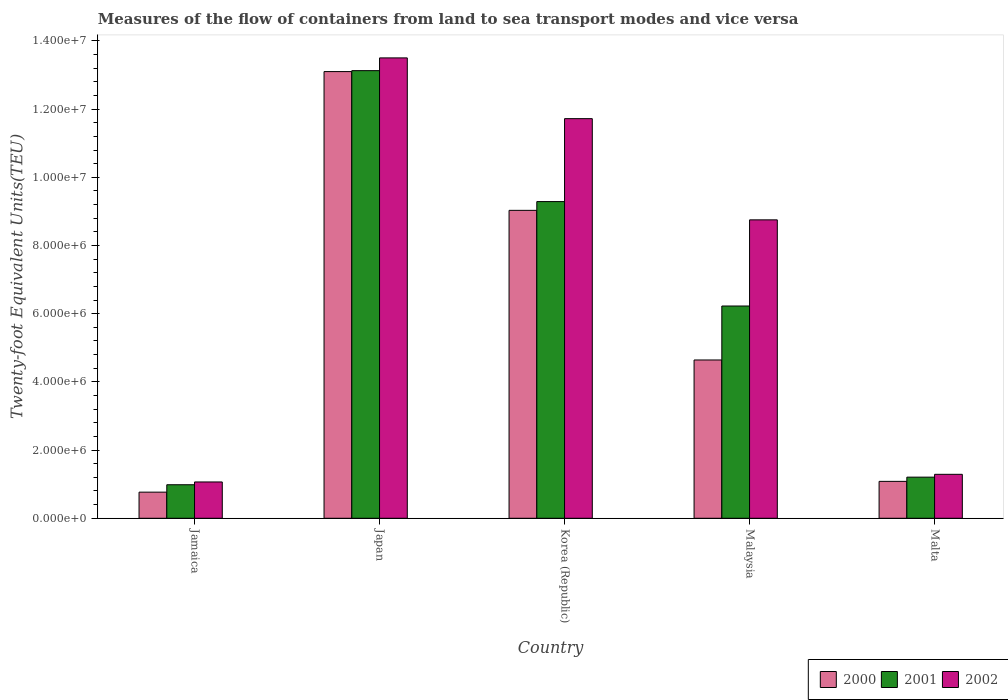How many groups of bars are there?
Offer a terse response. 5. Are the number of bars per tick equal to the number of legend labels?
Offer a very short reply. Yes. What is the label of the 1st group of bars from the left?
Provide a succinct answer. Jamaica. What is the container port traffic in 2001 in Korea (Republic)?
Your answer should be very brief. 9.29e+06. Across all countries, what is the maximum container port traffic in 2002?
Your response must be concise. 1.35e+07. Across all countries, what is the minimum container port traffic in 2000?
Give a very brief answer. 7.66e+05. In which country was the container port traffic in 2000 minimum?
Keep it short and to the point. Jamaica. What is the total container port traffic in 2000 in the graph?
Provide a succinct answer. 2.86e+07. What is the difference between the container port traffic in 2002 in Korea (Republic) and that in Malaysia?
Provide a succinct answer. 2.97e+06. What is the difference between the container port traffic in 2000 in Jamaica and the container port traffic in 2002 in Malaysia?
Offer a terse response. -7.99e+06. What is the average container port traffic in 2000 per country?
Provide a short and direct response. 5.72e+06. What is the difference between the container port traffic of/in 2001 and container port traffic of/in 2000 in Korea (Republic)?
Keep it short and to the point. 2.57e+05. What is the ratio of the container port traffic in 2001 in Jamaica to that in Japan?
Provide a short and direct response. 0.07. What is the difference between the highest and the second highest container port traffic in 2001?
Keep it short and to the point. 6.90e+06. What is the difference between the highest and the lowest container port traffic in 2002?
Keep it short and to the point. 1.24e+07. In how many countries, is the container port traffic in 2000 greater than the average container port traffic in 2000 taken over all countries?
Provide a short and direct response. 2. What does the 1st bar from the left in Japan represents?
Keep it short and to the point. 2000. How many bars are there?
Ensure brevity in your answer.  15. How many countries are there in the graph?
Make the answer very short. 5. What is the difference between two consecutive major ticks on the Y-axis?
Make the answer very short. 2.00e+06. Does the graph contain grids?
Your answer should be very brief. No. How many legend labels are there?
Your response must be concise. 3. How are the legend labels stacked?
Give a very brief answer. Horizontal. What is the title of the graph?
Provide a succinct answer. Measures of the flow of containers from land to sea transport modes and vice versa. What is the label or title of the X-axis?
Offer a terse response. Country. What is the label or title of the Y-axis?
Make the answer very short. Twenty-foot Equivalent Units(TEU). What is the Twenty-foot Equivalent Units(TEU) in 2000 in Jamaica?
Your response must be concise. 7.66e+05. What is the Twenty-foot Equivalent Units(TEU) of 2001 in Jamaica?
Provide a succinct answer. 9.83e+05. What is the Twenty-foot Equivalent Units(TEU) in 2002 in Jamaica?
Keep it short and to the point. 1.06e+06. What is the Twenty-foot Equivalent Units(TEU) of 2000 in Japan?
Provide a short and direct response. 1.31e+07. What is the Twenty-foot Equivalent Units(TEU) of 2001 in Japan?
Provide a short and direct response. 1.31e+07. What is the Twenty-foot Equivalent Units(TEU) in 2002 in Japan?
Make the answer very short. 1.35e+07. What is the Twenty-foot Equivalent Units(TEU) of 2000 in Korea (Republic)?
Make the answer very short. 9.03e+06. What is the Twenty-foot Equivalent Units(TEU) of 2001 in Korea (Republic)?
Keep it short and to the point. 9.29e+06. What is the Twenty-foot Equivalent Units(TEU) in 2002 in Korea (Republic)?
Offer a very short reply. 1.17e+07. What is the Twenty-foot Equivalent Units(TEU) in 2000 in Malaysia?
Your answer should be very brief. 4.64e+06. What is the Twenty-foot Equivalent Units(TEU) in 2001 in Malaysia?
Offer a very short reply. 6.22e+06. What is the Twenty-foot Equivalent Units(TEU) in 2002 in Malaysia?
Provide a short and direct response. 8.75e+06. What is the Twenty-foot Equivalent Units(TEU) in 2000 in Malta?
Your answer should be compact. 1.08e+06. What is the Twenty-foot Equivalent Units(TEU) in 2001 in Malta?
Offer a very short reply. 1.21e+06. What is the Twenty-foot Equivalent Units(TEU) of 2002 in Malta?
Your answer should be compact. 1.29e+06. Across all countries, what is the maximum Twenty-foot Equivalent Units(TEU) in 2000?
Provide a short and direct response. 1.31e+07. Across all countries, what is the maximum Twenty-foot Equivalent Units(TEU) in 2001?
Keep it short and to the point. 1.31e+07. Across all countries, what is the maximum Twenty-foot Equivalent Units(TEU) of 2002?
Keep it short and to the point. 1.35e+07. Across all countries, what is the minimum Twenty-foot Equivalent Units(TEU) in 2000?
Ensure brevity in your answer.  7.66e+05. Across all countries, what is the minimum Twenty-foot Equivalent Units(TEU) in 2001?
Ensure brevity in your answer.  9.83e+05. Across all countries, what is the minimum Twenty-foot Equivalent Units(TEU) of 2002?
Offer a very short reply. 1.06e+06. What is the total Twenty-foot Equivalent Units(TEU) of 2000 in the graph?
Offer a terse response. 2.86e+07. What is the total Twenty-foot Equivalent Units(TEU) of 2001 in the graph?
Your response must be concise. 3.08e+07. What is the total Twenty-foot Equivalent Units(TEU) in 2002 in the graph?
Your answer should be very brief. 3.63e+07. What is the difference between the Twenty-foot Equivalent Units(TEU) of 2000 in Jamaica and that in Japan?
Keep it short and to the point. -1.23e+07. What is the difference between the Twenty-foot Equivalent Units(TEU) of 2001 in Jamaica and that in Japan?
Give a very brief answer. -1.21e+07. What is the difference between the Twenty-foot Equivalent Units(TEU) in 2002 in Jamaica and that in Japan?
Your response must be concise. -1.24e+07. What is the difference between the Twenty-foot Equivalent Units(TEU) of 2000 in Jamaica and that in Korea (Republic)?
Offer a very short reply. -8.26e+06. What is the difference between the Twenty-foot Equivalent Units(TEU) of 2001 in Jamaica and that in Korea (Republic)?
Offer a very short reply. -8.30e+06. What is the difference between the Twenty-foot Equivalent Units(TEU) of 2002 in Jamaica and that in Korea (Republic)?
Your response must be concise. -1.07e+07. What is the difference between the Twenty-foot Equivalent Units(TEU) of 2000 in Jamaica and that in Malaysia?
Give a very brief answer. -3.88e+06. What is the difference between the Twenty-foot Equivalent Units(TEU) in 2001 in Jamaica and that in Malaysia?
Provide a short and direct response. -5.24e+06. What is the difference between the Twenty-foot Equivalent Units(TEU) of 2002 in Jamaica and that in Malaysia?
Provide a succinct answer. -7.69e+06. What is the difference between the Twenty-foot Equivalent Units(TEU) of 2000 in Jamaica and that in Malta?
Your answer should be very brief. -3.16e+05. What is the difference between the Twenty-foot Equivalent Units(TEU) of 2001 in Jamaica and that in Malta?
Your answer should be very brief. -2.22e+05. What is the difference between the Twenty-foot Equivalent Units(TEU) of 2002 in Jamaica and that in Malta?
Provide a short and direct response. -2.24e+05. What is the difference between the Twenty-foot Equivalent Units(TEU) in 2000 in Japan and that in Korea (Republic)?
Your answer should be compact. 4.07e+06. What is the difference between the Twenty-foot Equivalent Units(TEU) in 2001 in Japan and that in Korea (Republic)?
Your response must be concise. 3.84e+06. What is the difference between the Twenty-foot Equivalent Units(TEU) in 2002 in Japan and that in Korea (Republic)?
Your answer should be very brief. 1.78e+06. What is the difference between the Twenty-foot Equivalent Units(TEU) of 2000 in Japan and that in Malaysia?
Provide a succinct answer. 8.46e+06. What is the difference between the Twenty-foot Equivalent Units(TEU) in 2001 in Japan and that in Malaysia?
Your response must be concise. 6.90e+06. What is the difference between the Twenty-foot Equivalent Units(TEU) in 2002 in Japan and that in Malaysia?
Your response must be concise. 4.75e+06. What is the difference between the Twenty-foot Equivalent Units(TEU) in 2000 in Japan and that in Malta?
Provide a succinct answer. 1.20e+07. What is the difference between the Twenty-foot Equivalent Units(TEU) of 2001 in Japan and that in Malta?
Provide a succinct answer. 1.19e+07. What is the difference between the Twenty-foot Equivalent Units(TEU) in 2002 in Japan and that in Malta?
Keep it short and to the point. 1.22e+07. What is the difference between the Twenty-foot Equivalent Units(TEU) in 2000 in Korea (Republic) and that in Malaysia?
Offer a terse response. 4.39e+06. What is the difference between the Twenty-foot Equivalent Units(TEU) in 2001 in Korea (Republic) and that in Malaysia?
Keep it short and to the point. 3.06e+06. What is the difference between the Twenty-foot Equivalent Units(TEU) in 2002 in Korea (Republic) and that in Malaysia?
Provide a succinct answer. 2.97e+06. What is the difference between the Twenty-foot Equivalent Units(TEU) of 2000 in Korea (Republic) and that in Malta?
Your response must be concise. 7.95e+06. What is the difference between the Twenty-foot Equivalent Units(TEU) of 2001 in Korea (Republic) and that in Malta?
Your response must be concise. 8.08e+06. What is the difference between the Twenty-foot Equivalent Units(TEU) in 2002 in Korea (Republic) and that in Malta?
Offer a very short reply. 1.04e+07. What is the difference between the Twenty-foot Equivalent Units(TEU) in 2000 in Malaysia and that in Malta?
Provide a succinct answer. 3.56e+06. What is the difference between the Twenty-foot Equivalent Units(TEU) in 2001 in Malaysia and that in Malta?
Offer a very short reply. 5.02e+06. What is the difference between the Twenty-foot Equivalent Units(TEU) of 2002 in Malaysia and that in Malta?
Offer a very short reply. 7.46e+06. What is the difference between the Twenty-foot Equivalent Units(TEU) in 2000 in Jamaica and the Twenty-foot Equivalent Units(TEU) in 2001 in Japan?
Give a very brief answer. -1.24e+07. What is the difference between the Twenty-foot Equivalent Units(TEU) of 2000 in Jamaica and the Twenty-foot Equivalent Units(TEU) of 2002 in Japan?
Provide a short and direct response. -1.27e+07. What is the difference between the Twenty-foot Equivalent Units(TEU) of 2001 in Jamaica and the Twenty-foot Equivalent Units(TEU) of 2002 in Japan?
Your answer should be compact. -1.25e+07. What is the difference between the Twenty-foot Equivalent Units(TEU) in 2000 in Jamaica and the Twenty-foot Equivalent Units(TEU) in 2001 in Korea (Republic)?
Offer a terse response. -8.52e+06. What is the difference between the Twenty-foot Equivalent Units(TEU) of 2000 in Jamaica and the Twenty-foot Equivalent Units(TEU) of 2002 in Korea (Republic)?
Your answer should be compact. -1.10e+07. What is the difference between the Twenty-foot Equivalent Units(TEU) of 2001 in Jamaica and the Twenty-foot Equivalent Units(TEU) of 2002 in Korea (Republic)?
Keep it short and to the point. -1.07e+07. What is the difference between the Twenty-foot Equivalent Units(TEU) of 2000 in Jamaica and the Twenty-foot Equivalent Units(TEU) of 2001 in Malaysia?
Keep it short and to the point. -5.46e+06. What is the difference between the Twenty-foot Equivalent Units(TEU) of 2000 in Jamaica and the Twenty-foot Equivalent Units(TEU) of 2002 in Malaysia?
Make the answer very short. -7.99e+06. What is the difference between the Twenty-foot Equivalent Units(TEU) in 2001 in Jamaica and the Twenty-foot Equivalent Units(TEU) in 2002 in Malaysia?
Provide a short and direct response. -7.77e+06. What is the difference between the Twenty-foot Equivalent Units(TEU) of 2000 in Jamaica and the Twenty-foot Equivalent Units(TEU) of 2001 in Malta?
Provide a short and direct response. -4.40e+05. What is the difference between the Twenty-foot Equivalent Units(TEU) of 2000 in Jamaica and the Twenty-foot Equivalent Units(TEU) of 2002 in Malta?
Give a very brief answer. -5.23e+05. What is the difference between the Twenty-foot Equivalent Units(TEU) in 2001 in Jamaica and the Twenty-foot Equivalent Units(TEU) in 2002 in Malta?
Offer a very short reply. -3.05e+05. What is the difference between the Twenty-foot Equivalent Units(TEU) in 2000 in Japan and the Twenty-foot Equivalent Units(TEU) in 2001 in Korea (Republic)?
Provide a short and direct response. 3.81e+06. What is the difference between the Twenty-foot Equivalent Units(TEU) of 2000 in Japan and the Twenty-foot Equivalent Units(TEU) of 2002 in Korea (Republic)?
Keep it short and to the point. 1.38e+06. What is the difference between the Twenty-foot Equivalent Units(TEU) of 2001 in Japan and the Twenty-foot Equivalent Units(TEU) of 2002 in Korea (Republic)?
Your answer should be very brief. 1.41e+06. What is the difference between the Twenty-foot Equivalent Units(TEU) in 2000 in Japan and the Twenty-foot Equivalent Units(TEU) in 2001 in Malaysia?
Your answer should be compact. 6.88e+06. What is the difference between the Twenty-foot Equivalent Units(TEU) in 2000 in Japan and the Twenty-foot Equivalent Units(TEU) in 2002 in Malaysia?
Provide a short and direct response. 4.35e+06. What is the difference between the Twenty-foot Equivalent Units(TEU) in 2001 in Japan and the Twenty-foot Equivalent Units(TEU) in 2002 in Malaysia?
Keep it short and to the point. 4.38e+06. What is the difference between the Twenty-foot Equivalent Units(TEU) in 2000 in Japan and the Twenty-foot Equivalent Units(TEU) in 2001 in Malta?
Your response must be concise. 1.19e+07. What is the difference between the Twenty-foot Equivalent Units(TEU) in 2000 in Japan and the Twenty-foot Equivalent Units(TEU) in 2002 in Malta?
Provide a short and direct response. 1.18e+07. What is the difference between the Twenty-foot Equivalent Units(TEU) of 2001 in Japan and the Twenty-foot Equivalent Units(TEU) of 2002 in Malta?
Your answer should be very brief. 1.18e+07. What is the difference between the Twenty-foot Equivalent Units(TEU) of 2000 in Korea (Republic) and the Twenty-foot Equivalent Units(TEU) of 2001 in Malaysia?
Provide a succinct answer. 2.81e+06. What is the difference between the Twenty-foot Equivalent Units(TEU) of 2000 in Korea (Republic) and the Twenty-foot Equivalent Units(TEU) of 2002 in Malaysia?
Offer a terse response. 2.79e+05. What is the difference between the Twenty-foot Equivalent Units(TEU) in 2001 in Korea (Republic) and the Twenty-foot Equivalent Units(TEU) in 2002 in Malaysia?
Ensure brevity in your answer.  5.36e+05. What is the difference between the Twenty-foot Equivalent Units(TEU) in 2000 in Korea (Republic) and the Twenty-foot Equivalent Units(TEU) in 2001 in Malta?
Ensure brevity in your answer.  7.82e+06. What is the difference between the Twenty-foot Equivalent Units(TEU) in 2000 in Korea (Republic) and the Twenty-foot Equivalent Units(TEU) in 2002 in Malta?
Your answer should be compact. 7.74e+06. What is the difference between the Twenty-foot Equivalent Units(TEU) in 2001 in Korea (Republic) and the Twenty-foot Equivalent Units(TEU) in 2002 in Malta?
Offer a terse response. 8.00e+06. What is the difference between the Twenty-foot Equivalent Units(TEU) in 2000 in Malaysia and the Twenty-foot Equivalent Units(TEU) in 2001 in Malta?
Keep it short and to the point. 3.44e+06. What is the difference between the Twenty-foot Equivalent Units(TEU) in 2000 in Malaysia and the Twenty-foot Equivalent Units(TEU) in 2002 in Malta?
Give a very brief answer. 3.35e+06. What is the difference between the Twenty-foot Equivalent Units(TEU) of 2001 in Malaysia and the Twenty-foot Equivalent Units(TEU) of 2002 in Malta?
Ensure brevity in your answer.  4.94e+06. What is the average Twenty-foot Equivalent Units(TEU) of 2000 per country?
Offer a terse response. 5.72e+06. What is the average Twenty-foot Equivalent Units(TEU) of 2001 per country?
Ensure brevity in your answer.  6.17e+06. What is the average Twenty-foot Equivalent Units(TEU) of 2002 per country?
Make the answer very short. 7.27e+06. What is the difference between the Twenty-foot Equivalent Units(TEU) of 2000 and Twenty-foot Equivalent Units(TEU) of 2001 in Jamaica?
Your answer should be compact. -2.17e+05. What is the difference between the Twenty-foot Equivalent Units(TEU) in 2000 and Twenty-foot Equivalent Units(TEU) in 2002 in Jamaica?
Make the answer very short. -2.99e+05. What is the difference between the Twenty-foot Equivalent Units(TEU) of 2001 and Twenty-foot Equivalent Units(TEU) of 2002 in Jamaica?
Your answer should be compact. -8.16e+04. What is the difference between the Twenty-foot Equivalent Units(TEU) of 2000 and Twenty-foot Equivalent Units(TEU) of 2001 in Japan?
Keep it short and to the point. -2.71e+04. What is the difference between the Twenty-foot Equivalent Units(TEU) in 2000 and Twenty-foot Equivalent Units(TEU) in 2002 in Japan?
Your answer should be very brief. -4.01e+05. What is the difference between the Twenty-foot Equivalent Units(TEU) of 2001 and Twenty-foot Equivalent Units(TEU) of 2002 in Japan?
Provide a succinct answer. -3.74e+05. What is the difference between the Twenty-foot Equivalent Units(TEU) in 2000 and Twenty-foot Equivalent Units(TEU) in 2001 in Korea (Republic)?
Give a very brief answer. -2.57e+05. What is the difference between the Twenty-foot Equivalent Units(TEU) in 2000 and Twenty-foot Equivalent Units(TEU) in 2002 in Korea (Republic)?
Provide a succinct answer. -2.69e+06. What is the difference between the Twenty-foot Equivalent Units(TEU) in 2001 and Twenty-foot Equivalent Units(TEU) in 2002 in Korea (Republic)?
Your response must be concise. -2.43e+06. What is the difference between the Twenty-foot Equivalent Units(TEU) in 2000 and Twenty-foot Equivalent Units(TEU) in 2001 in Malaysia?
Ensure brevity in your answer.  -1.58e+06. What is the difference between the Twenty-foot Equivalent Units(TEU) in 2000 and Twenty-foot Equivalent Units(TEU) in 2002 in Malaysia?
Ensure brevity in your answer.  -4.11e+06. What is the difference between the Twenty-foot Equivalent Units(TEU) of 2001 and Twenty-foot Equivalent Units(TEU) of 2002 in Malaysia?
Make the answer very short. -2.53e+06. What is the difference between the Twenty-foot Equivalent Units(TEU) in 2000 and Twenty-foot Equivalent Units(TEU) in 2001 in Malta?
Ensure brevity in your answer.  -1.24e+05. What is the difference between the Twenty-foot Equivalent Units(TEU) of 2000 and Twenty-foot Equivalent Units(TEU) of 2002 in Malta?
Your response must be concise. -2.07e+05. What is the difference between the Twenty-foot Equivalent Units(TEU) of 2001 and Twenty-foot Equivalent Units(TEU) of 2002 in Malta?
Your answer should be very brief. -8.30e+04. What is the ratio of the Twenty-foot Equivalent Units(TEU) in 2000 in Jamaica to that in Japan?
Your answer should be very brief. 0.06. What is the ratio of the Twenty-foot Equivalent Units(TEU) of 2001 in Jamaica to that in Japan?
Provide a short and direct response. 0.07. What is the ratio of the Twenty-foot Equivalent Units(TEU) of 2002 in Jamaica to that in Japan?
Provide a succinct answer. 0.08. What is the ratio of the Twenty-foot Equivalent Units(TEU) in 2000 in Jamaica to that in Korea (Republic)?
Give a very brief answer. 0.08. What is the ratio of the Twenty-foot Equivalent Units(TEU) of 2001 in Jamaica to that in Korea (Republic)?
Your answer should be compact. 0.11. What is the ratio of the Twenty-foot Equivalent Units(TEU) of 2002 in Jamaica to that in Korea (Republic)?
Your response must be concise. 0.09. What is the ratio of the Twenty-foot Equivalent Units(TEU) of 2000 in Jamaica to that in Malaysia?
Your answer should be compact. 0.17. What is the ratio of the Twenty-foot Equivalent Units(TEU) in 2001 in Jamaica to that in Malaysia?
Ensure brevity in your answer.  0.16. What is the ratio of the Twenty-foot Equivalent Units(TEU) in 2002 in Jamaica to that in Malaysia?
Keep it short and to the point. 0.12. What is the ratio of the Twenty-foot Equivalent Units(TEU) in 2000 in Jamaica to that in Malta?
Your answer should be compact. 0.71. What is the ratio of the Twenty-foot Equivalent Units(TEU) in 2001 in Jamaica to that in Malta?
Your response must be concise. 0.82. What is the ratio of the Twenty-foot Equivalent Units(TEU) of 2002 in Jamaica to that in Malta?
Provide a short and direct response. 0.83. What is the ratio of the Twenty-foot Equivalent Units(TEU) of 2000 in Japan to that in Korea (Republic)?
Ensure brevity in your answer.  1.45. What is the ratio of the Twenty-foot Equivalent Units(TEU) in 2001 in Japan to that in Korea (Republic)?
Ensure brevity in your answer.  1.41. What is the ratio of the Twenty-foot Equivalent Units(TEU) in 2002 in Japan to that in Korea (Republic)?
Give a very brief answer. 1.15. What is the ratio of the Twenty-foot Equivalent Units(TEU) of 2000 in Japan to that in Malaysia?
Ensure brevity in your answer.  2.82. What is the ratio of the Twenty-foot Equivalent Units(TEU) in 2001 in Japan to that in Malaysia?
Make the answer very short. 2.11. What is the ratio of the Twenty-foot Equivalent Units(TEU) of 2002 in Japan to that in Malaysia?
Make the answer very short. 1.54. What is the ratio of the Twenty-foot Equivalent Units(TEU) in 2000 in Japan to that in Malta?
Give a very brief answer. 12.1. What is the ratio of the Twenty-foot Equivalent Units(TEU) in 2001 in Japan to that in Malta?
Provide a short and direct response. 10.89. What is the ratio of the Twenty-foot Equivalent Units(TEU) in 2002 in Japan to that in Malta?
Keep it short and to the point. 10.48. What is the ratio of the Twenty-foot Equivalent Units(TEU) in 2000 in Korea (Republic) to that in Malaysia?
Provide a short and direct response. 1.95. What is the ratio of the Twenty-foot Equivalent Units(TEU) in 2001 in Korea (Republic) to that in Malaysia?
Ensure brevity in your answer.  1.49. What is the ratio of the Twenty-foot Equivalent Units(TEU) in 2002 in Korea (Republic) to that in Malaysia?
Your answer should be compact. 1.34. What is the ratio of the Twenty-foot Equivalent Units(TEU) in 2000 in Korea (Republic) to that in Malta?
Keep it short and to the point. 8.34. What is the ratio of the Twenty-foot Equivalent Units(TEU) of 2001 in Korea (Republic) to that in Malta?
Give a very brief answer. 7.7. What is the ratio of the Twenty-foot Equivalent Units(TEU) in 2002 in Korea (Republic) to that in Malta?
Keep it short and to the point. 9.09. What is the ratio of the Twenty-foot Equivalent Units(TEU) in 2000 in Malaysia to that in Malta?
Your answer should be compact. 4.29. What is the ratio of the Twenty-foot Equivalent Units(TEU) of 2001 in Malaysia to that in Malta?
Your answer should be compact. 5.16. What is the ratio of the Twenty-foot Equivalent Units(TEU) of 2002 in Malaysia to that in Malta?
Your answer should be compact. 6.79. What is the difference between the highest and the second highest Twenty-foot Equivalent Units(TEU) of 2000?
Keep it short and to the point. 4.07e+06. What is the difference between the highest and the second highest Twenty-foot Equivalent Units(TEU) of 2001?
Give a very brief answer. 3.84e+06. What is the difference between the highest and the second highest Twenty-foot Equivalent Units(TEU) of 2002?
Ensure brevity in your answer.  1.78e+06. What is the difference between the highest and the lowest Twenty-foot Equivalent Units(TEU) in 2000?
Keep it short and to the point. 1.23e+07. What is the difference between the highest and the lowest Twenty-foot Equivalent Units(TEU) of 2001?
Keep it short and to the point. 1.21e+07. What is the difference between the highest and the lowest Twenty-foot Equivalent Units(TEU) in 2002?
Make the answer very short. 1.24e+07. 